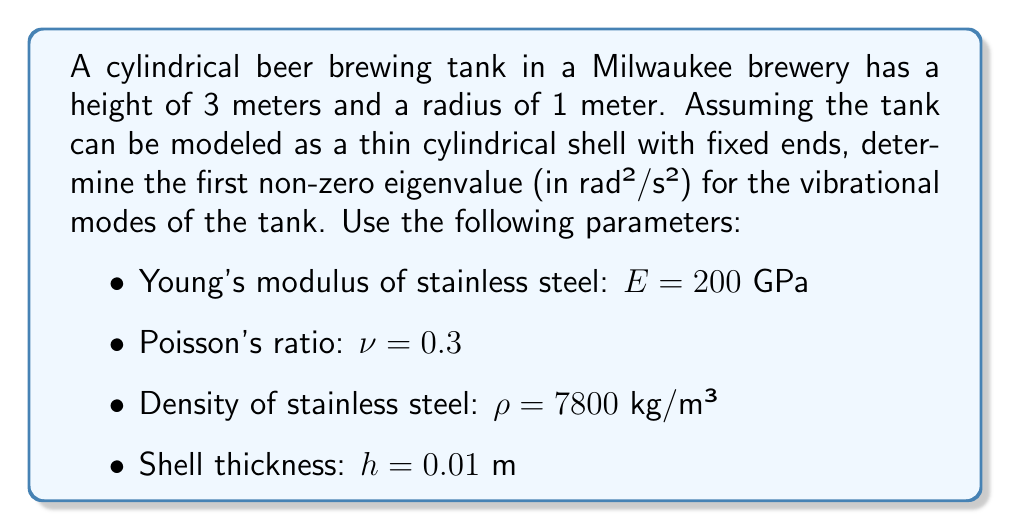Show me your answer to this math problem. To solve this problem, we'll follow these steps:

1) The eigenvalues for a cylindrical shell with fixed ends are given by:

   $$\omega_{mn}^2 = \frac{E}{\rho(1-\nu^2)}\left(\frac{h^2}{12R^2}\right)\left[m^2\pi^2\frac{R^2}{L^2} + n^2 + 1\right]^2$$

   where $m$ and $n$ are mode numbers, $R$ is the radius, and $L$ is the length of the cylinder.

2) The first non-zero eigenvalue occurs when $m=1$ and $n=0$. Substituting these values:

   $$\omega_{10}^2 = \frac{E}{\rho(1-\nu^2)}\left(\frac{h^2}{12R^2}\right)\left[\pi^2\frac{R^2}{L^2} + 1\right]^2$$

3) Now, let's substitute the given values:
   $E = 200 \times 10^9$ Pa
   $\rho = 7800$ kg/m³
   $\nu = 0.3$
   $h = 0.01$ m
   $R = 1$ m
   $L = 3$ m

4) First, calculate $1-\nu^2$:
   $1-\nu^2 = 1 - 0.3^2 = 0.91$

5) Then, calculate $\frac{h^2}{12R^2}$:
   $\frac{h^2}{12R^2} = \frac{0.01^2}{12 \times 1^2} = 8.33 \times 10^{-6}$

6) Calculate $\pi^2\frac{R^2}{L^2} + 1$:
   $\pi^2\frac{R^2}{L^2} + 1 = \pi^2\frac{1^2}{3^2} + 1 = 1.11$

7) Now, put it all together:

   $$\omega_{10}^2 = \frac{200 \times 10^9}{7800 \times 0.91} \times 8.33 \times 10^{-6} \times 1.11^2 = 2590.7$$

8) Therefore, the first non-zero eigenvalue is approximately 2590.7 rad²/s².
Answer: 2590.7 rad²/s² 